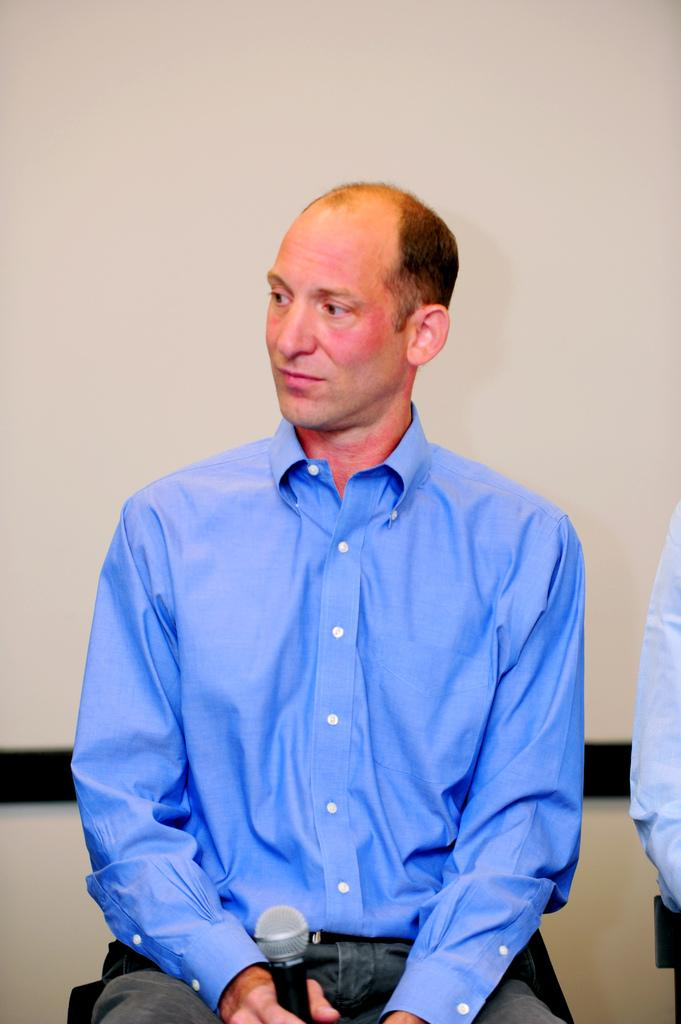What is the man in the image doing? The man is sitting in the image. What is the man holding in the image? The man is holding a microphone. What can be seen in the background of the image? There is a wall in the background of the image. What is on the left side of the image? There is cloth on the left side of the image. What type of collar is the plough wearing in the image? There is no plough or collar present in the image. 